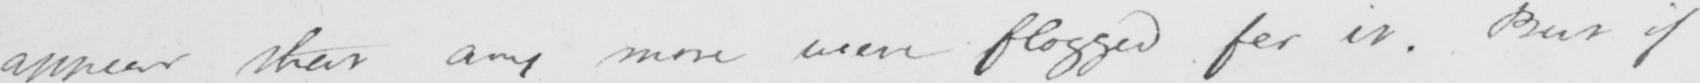Can you read and transcribe this handwriting? appear that any more were flogged for it . But if 